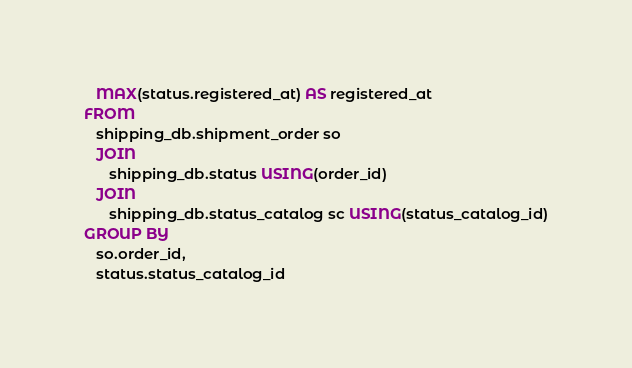Convert code to text. <code><loc_0><loc_0><loc_500><loc_500><_SQL_>   MAX(status.registered_at) AS registered_at
FROM
   shipping_db.shipment_order so
   JOIN
      shipping_db.status USING(order_id)
   JOIN
      shipping_db.status_catalog sc USING(status_catalog_id)
GROUP BY
   so.order_id,
   status.status_catalog_id
</code> 